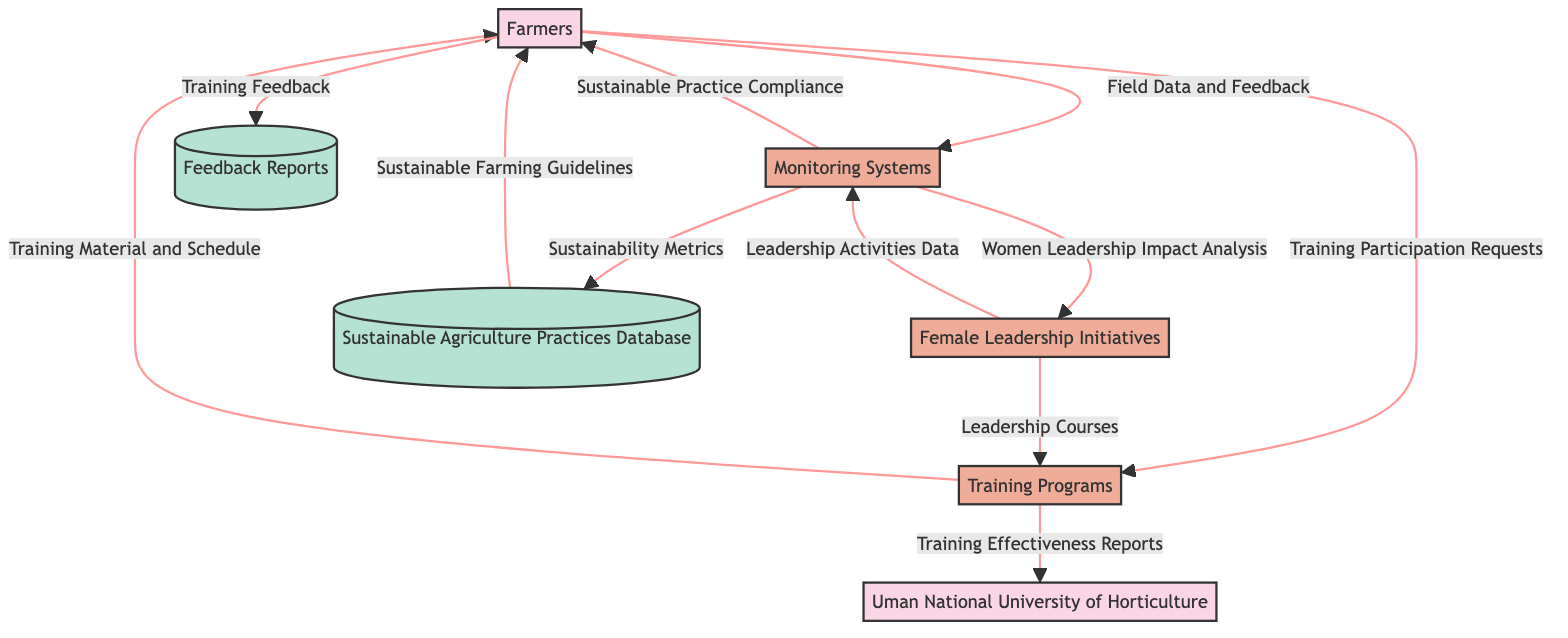What are the external entities in the diagram? There are two external entities listed in the diagram: Farmers and Uman National University of Horticulture.
Answer: Farmers, Uman National University of Horticulture How many processes are shown in the diagram? The diagram displays three processes: Female Leadership Initiatives, Training Programs, and Monitoring Systems.
Answer: 3 Which entity provides Leadership Courses to the Training Programs? The Female Leadership Initiatives provide Leadership Courses to the Training Programs.
Answer: Female Leadership Initiatives What type of data do Farmers provide to the Monitoring Systems? Farmers provide Field Data and Feedback to the Monitoring Systems.
Answer: Field Data and Feedback What data is sent from Monitoring Systems to the Sustainable Agriculture Practices Database? The Sustainability Metrics are sent from the Monitoring Systems to the Sustainable Agriculture Practices Database.
Answer: Sustainability Metrics How many data stores are represented in the diagram? The diagram contains two data stores: Sustainable Agriculture Practices Database and Feedback Reports.
Answer: 2 What is the output data from Training Programs to Farmers? The Training Programs send Training Material and Schedule to Farmers.
Answer: Training Material and Schedule Which process receives Training Effectiveness Reports from Training Programs? The Uman National University of Horticulture receives Training Effectiveness Reports from the Training Programs.
Answer: Uman National University of Horticulture What is the flow of data from Monitoring Systems to Female Leadership Initiatives? The Monitoring Systems send Women Leadership Impact Analysis to the Female Leadership Initiatives.
Answer: Women Leadership Impact Analysis 